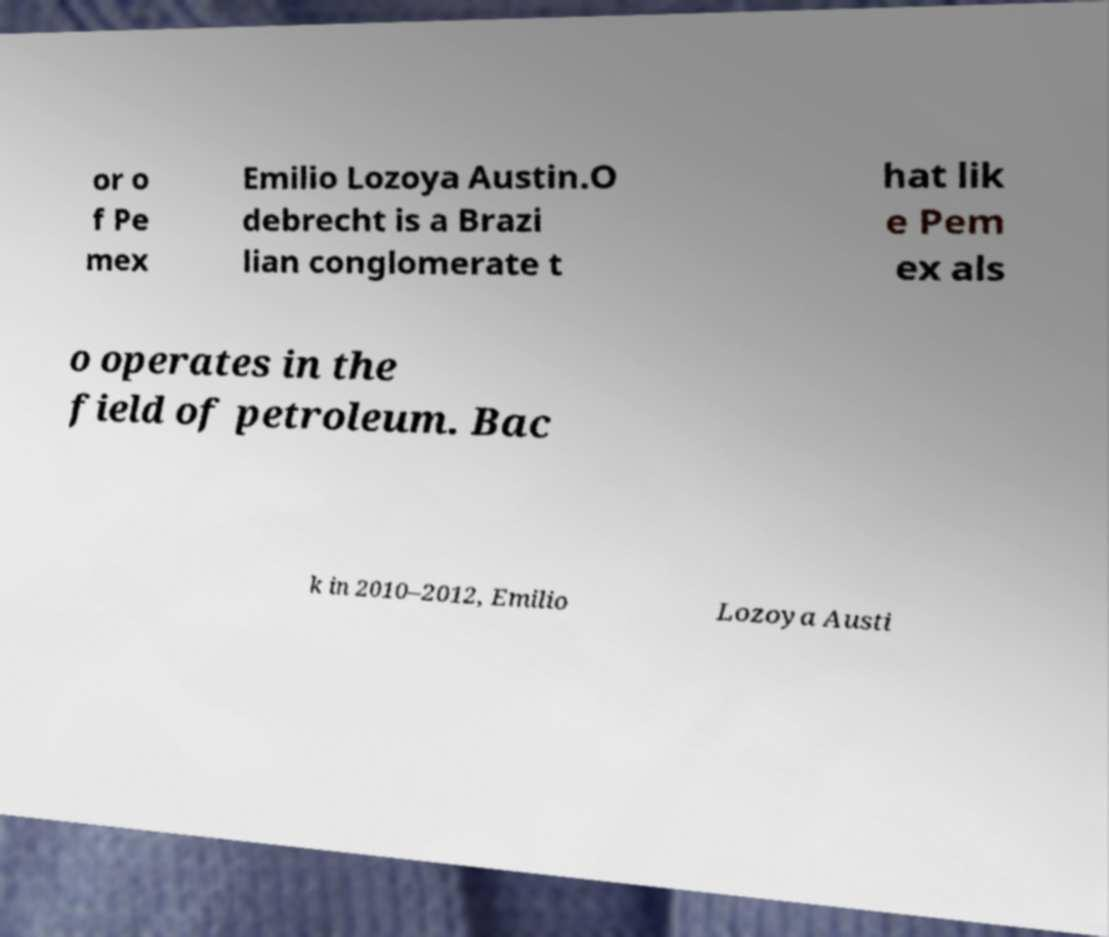Please identify and transcribe the text found in this image. or o f Pe mex Emilio Lozoya Austin.O debrecht is a Brazi lian conglomerate t hat lik e Pem ex als o operates in the field of petroleum. Bac k in 2010–2012, Emilio Lozoya Austi 